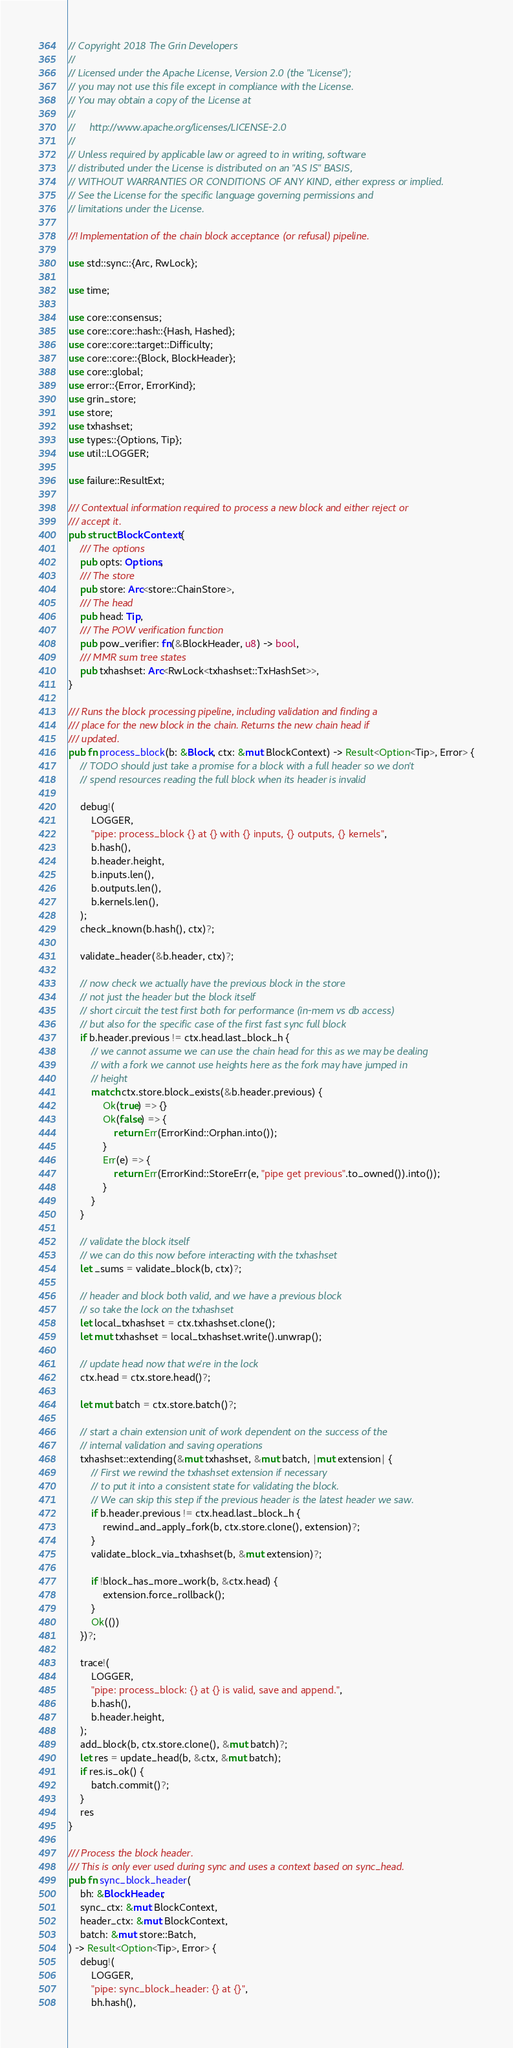Convert code to text. <code><loc_0><loc_0><loc_500><loc_500><_Rust_>// Copyright 2018 The Grin Developers
//
// Licensed under the Apache License, Version 2.0 (the "License");
// you may not use this file except in compliance with the License.
// You may obtain a copy of the License at
//
//     http://www.apache.org/licenses/LICENSE-2.0
//
// Unless required by applicable law or agreed to in writing, software
// distributed under the License is distributed on an "AS IS" BASIS,
// WITHOUT WARRANTIES OR CONDITIONS OF ANY KIND, either express or implied.
// See the License for the specific language governing permissions and
// limitations under the License.

//! Implementation of the chain block acceptance (or refusal) pipeline.

use std::sync::{Arc, RwLock};

use time;

use core::consensus;
use core::core::hash::{Hash, Hashed};
use core::core::target::Difficulty;
use core::core::{Block, BlockHeader};
use core::global;
use error::{Error, ErrorKind};
use grin_store;
use store;
use txhashset;
use types::{Options, Tip};
use util::LOGGER;

use failure::ResultExt;

/// Contextual information required to process a new block and either reject or
/// accept it.
pub struct BlockContext {
	/// The options
	pub opts: Options,
	/// The store
	pub store: Arc<store::ChainStore>,
	/// The head
	pub head: Tip,
	/// The POW verification function
	pub pow_verifier: fn(&BlockHeader, u8) -> bool,
	/// MMR sum tree states
	pub txhashset: Arc<RwLock<txhashset::TxHashSet>>,
}

/// Runs the block processing pipeline, including validation and finding a
/// place for the new block in the chain. Returns the new chain head if
/// updated.
pub fn process_block(b: &Block, ctx: &mut BlockContext) -> Result<Option<Tip>, Error> {
	// TODO should just take a promise for a block with a full header so we don't
	// spend resources reading the full block when its header is invalid

	debug!(
		LOGGER,
		"pipe: process_block {} at {} with {} inputs, {} outputs, {} kernels",
		b.hash(),
		b.header.height,
		b.inputs.len(),
		b.outputs.len(),
		b.kernels.len(),
	);
	check_known(b.hash(), ctx)?;

	validate_header(&b.header, ctx)?;

	// now check we actually have the previous block in the store
	// not just the header but the block itself
	// short circuit the test first both for performance (in-mem vs db access)
	// but also for the specific case of the first fast sync full block
	if b.header.previous != ctx.head.last_block_h {
		// we cannot assume we can use the chain head for this as we may be dealing
		// with a fork we cannot use heights here as the fork may have jumped in
		// height
		match ctx.store.block_exists(&b.header.previous) {
			Ok(true) => {}
			Ok(false) => {
				return Err(ErrorKind::Orphan.into());
			}
			Err(e) => {
				return Err(ErrorKind::StoreErr(e, "pipe get previous".to_owned()).into());
			}
		}
	}

	// validate the block itself
	// we can do this now before interacting with the txhashset
	let _sums = validate_block(b, ctx)?;

	// header and block both valid, and we have a previous block
	// so take the lock on the txhashset
	let local_txhashset = ctx.txhashset.clone();
	let mut txhashset = local_txhashset.write().unwrap();

	// update head now that we're in the lock
	ctx.head = ctx.store.head()?;

	let mut batch = ctx.store.batch()?;

	// start a chain extension unit of work dependent on the success of the
	// internal validation and saving operations
	txhashset::extending(&mut txhashset, &mut batch, |mut extension| {
		// First we rewind the txhashset extension if necessary
		// to put it into a consistent state for validating the block.
		// We can skip this step if the previous header is the latest header we saw.
		if b.header.previous != ctx.head.last_block_h {
			rewind_and_apply_fork(b, ctx.store.clone(), extension)?;
		}
		validate_block_via_txhashset(b, &mut extension)?;

		if !block_has_more_work(b, &ctx.head) {
			extension.force_rollback();
		}
		Ok(())
	})?;

	trace!(
		LOGGER,
		"pipe: process_block: {} at {} is valid, save and append.",
		b.hash(),
		b.header.height,
	);
	add_block(b, ctx.store.clone(), &mut batch)?;
	let res = update_head(b, &ctx, &mut batch);
	if res.is_ok() {
		batch.commit()?;
	}
	res
}

/// Process the block header.
/// This is only ever used during sync and uses a context based on sync_head.
pub fn sync_block_header(
	bh: &BlockHeader,
	sync_ctx: &mut BlockContext,
	header_ctx: &mut BlockContext,
	batch: &mut store::Batch,
) -> Result<Option<Tip>, Error> {
	debug!(
		LOGGER,
		"pipe: sync_block_header: {} at {}",
		bh.hash(),</code> 